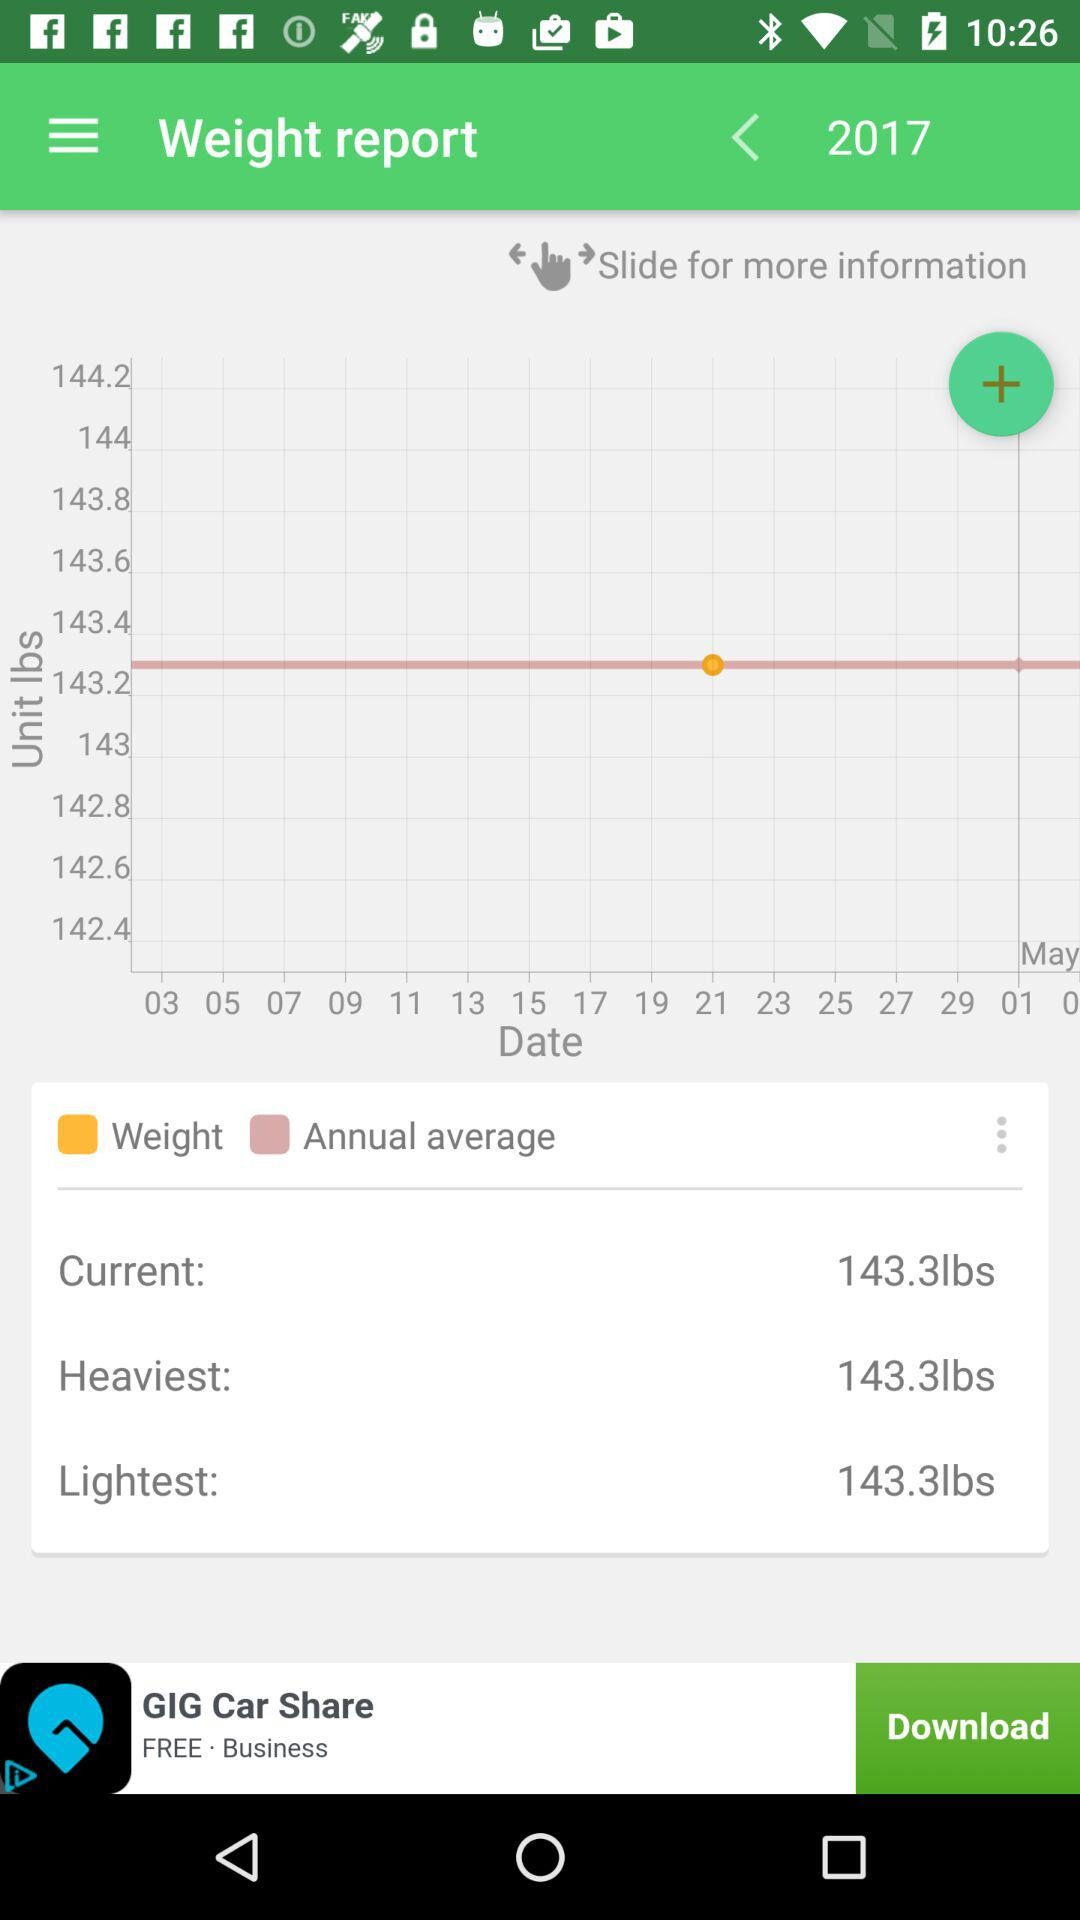What is the lightest weight in the weight report? The lightest weight is 143.3 lbs. 